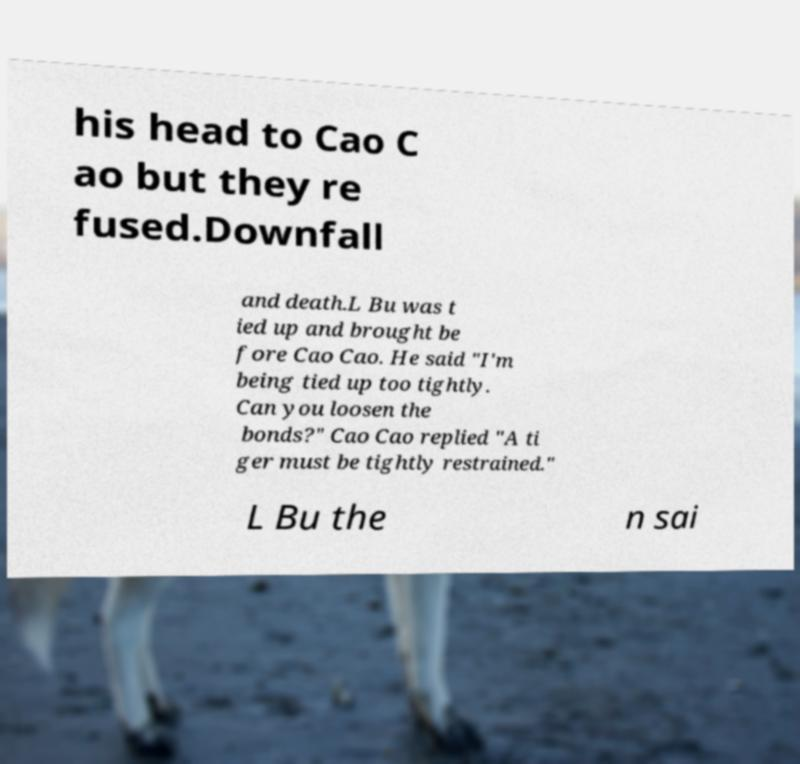Please read and relay the text visible in this image. What does it say? his head to Cao C ao but they re fused.Downfall and death.L Bu was t ied up and brought be fore Cao Cao. He said "I'm being tied up too tightly. Can you loosen the bonds?" Cao Cao replied "A ti ger must be tightly restrained." L Bu the n sai 